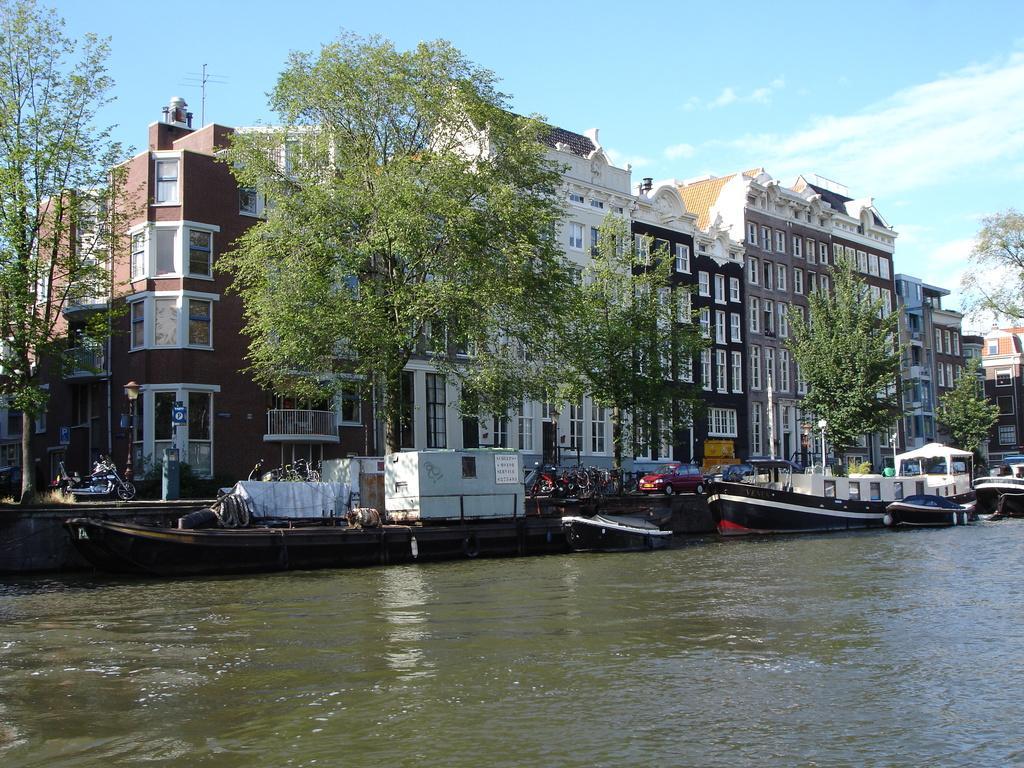Can you describe this image briefly? In this picture I can see boats on the water. There are vehicles, buildings, trees, and in the background there is the sky. 